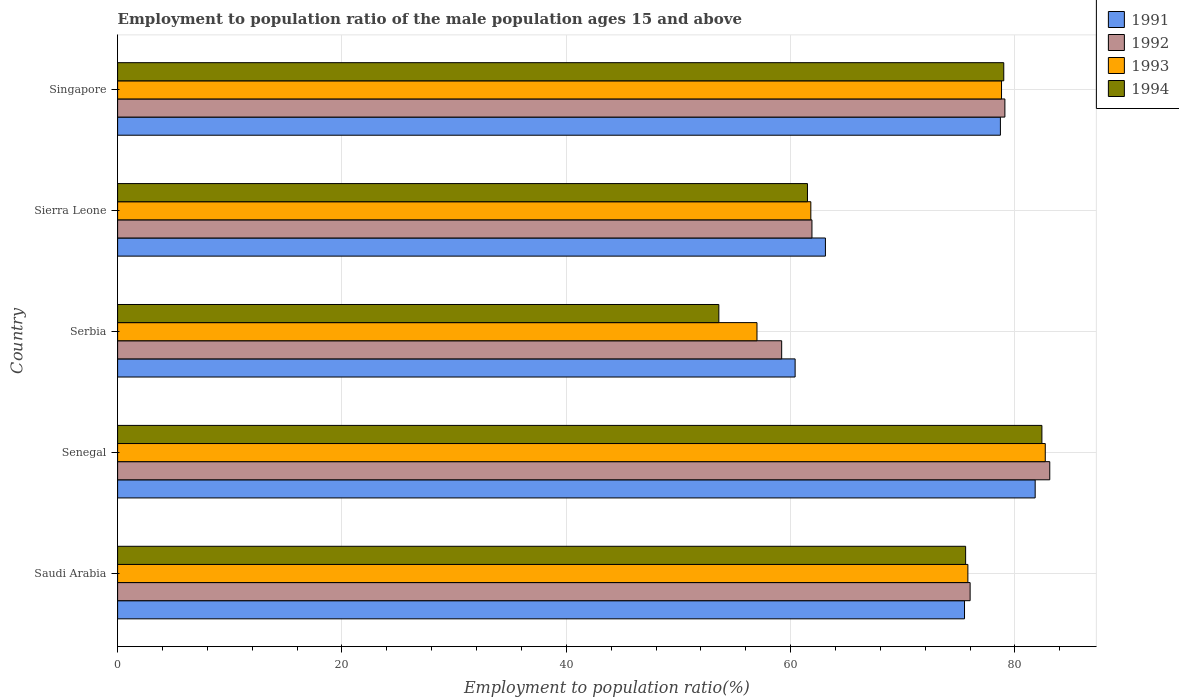How many groups of bars are there?
Your response must be concise. 5. Are the number of bars per tick equal to the number of legend labels?
Provide a succinct answer. Yes. How many bars are there on the 4th tick from the top?
Your answer should be very brief. 4. What is the label of the 5th group of bars from the top?
Provide a succinct answer. Saudi Arabia. In how many cases, is the number of bars for a given country not equal to the number of legend labels?
Your response must be concise. 0. Across all countries, what is the maximum employment to population ratio in 1993?
Offer a terse response. 82.7. Across all countries, what is the minimum employment to population ratio in 1993?
Make the answer very short. 57. In which country was the employment to population ratio in 1993 maximum?
Give a very brief answer. Senegal. In which country was the employment to population ratio in 1993 minimum?
Give a very brief answer. Serbia. What is the total employment to population ratio in 1991 in the graph?
Your answer should be compact. 359.5. What is the difference between the employment to population ratio in 1991 in Saudi Arabia and that in Singapore?
Offer a very short reply. -3.2. What is the difference between the employment to population ratio in 1994 in Singapore and the employment to population ratio in 1991 in Saudi Arabia?
Provide a succinct answer. 3.5. What is the average employment to population ratio in 1991 per country?
Your answer should be compact. 71.9. What is the difference between the employment to population ratio in 1991 and employment to population ratio in 1992 in Singapore?
Your answer should be compact. -0.4. What is the ratio of the employment to population ratio in 1992 in Saudi Arabia to that in Serbia?
Offer a very short reply. 1.28. Is the difference between the employment to population ratio in 1991 in Saudi Arabia and Senegal greater than the difference between the employment to population ratio in 1992 in Saudi Arabia and Senegal?
Offer a terse response. Yes. What is the difference between the highest and the second highest employment to population ratio in 1994?
Keep it short and to the point. 3.4. What is the difference between the highest and the lowest employment to population ratio in 1994?
Offer a terse response. 28.8. Is it the case that in every country, the sum of the employment to population ratio in 1991 and employment to population ratio in 1994 is greater than the employment to population ratio in 1993?
Ensure brevity in your answer.  Yes. How many countries are there in the graph?
Your answer should be very brief. 5. Does the graph contain any zero values?
Offer a terse response. No. What is the title of the graph?
Your answer should be compact. Employment to population ratio of the male population ages 15 and above. What is the Employment to population ratio(%) in 1991 in Saudi Arabia?
Provide a succinct answer. 75.5. What is the Employment to population ratio(%) in 1992 in Saudi Arabia?
Give a very brief answer. 76. What is the Employment to population ratio(%) in 1993 in Saudi Arabia?
Give a very brief answer. 75.8. What is the Employment to population ratio(%) in 1994 in Saudi Arabia?
Your answer should be compact. 75.6. What is the Employment to population ratio(%) in 1991 in Senegal?
Give a very brief answer. 81.8. What is the Employment to population ratio(%) in 1992 in Senegal?
Your response must be concise. 83.1. What is the Employment to population ratio(%) of 1993 in Senegal?
Give a very brief answer. 82.7. What is the Employment to population ratio(%) in 1994 in Senegal?
Ensure brevity in your answer.  82.4. What is the Employment to population ratio(%) in 1991 in Serbia?
Offer a terse response. 60.4. What is the Employment to population ratio(%) of 1992 in Serbia?
Provide a short and direct response. 59.2. What is the Employment to population ratio(%) in 1994 in Serbia?
Make the answer very short. 53.6. What is the Employment to population ratio(%) of 1991 in Sierra Leone?
Give a very brief answer. 63.1. What is the Employment to population ratio(%) in 1992 in Sierra Leone?
Keep it short and to the point. 61.9. What is the Employment to population ratio(%) in 1993 in Sierra Leone?
Give a very brief answer. 61.8. What is the Employment to population ratio(%) in 1994 in Sierra Leone?
Provide a succinct answer. 61.5. What is the Employment to population ratio(%) in 1991 in Singapore?
Your answer should be compact. 78.7. What is the Employment to population ratio(%) of 1992 in Singapore?
Give a very brief answer. 79.1. What is the Employment to population ratio(%) in 1993 in Singapore?
Provide a short and direct response. 78.8. What is the Employment to population ratio(%) in 1994 in Singapore?
Your answer should be compact. 79. Across all countries, what is the maximum Employment to population ratio(%) of 1991?
Your response must be concise. 81.8. Across all countries, what is the maximum Employment to population ratio(%) of 1992?
Offer a terse response. 83.1. Across all countries, what is the maximum Employment to population ratio(%) of 1993?
Provide a succinct answer. 82.7. Across all countries, what is the maximum Employment to population ratio(%) of 1994?
Your answer should be compact. 82.4. Across all countries, what is the minimum Employment to population ratio(%) of 1991?
Make the answer very short. 60.4. Across all countries, what is the minimum Employment to population ratio(%) of 1992?
Your answer should be compact. 59.2. Across all countries, what is the minimum Employment to population ratio(%) of 1994?
Offer a very short reply. 53.6. What is the total Employment to population ratio(%) in 1991 in the graph?
Keep it short and to the point. 359.5. What is the total Employment to population ratio(%) in 1992 in the graph?
Ensure brevity in your answer.  359.3. What is the total Employment to population ratio(%) of 1993 in the graph?
Provide a succinct answer. 356.1. What is the total Employment to population ratio(%) in 1994 in the graph?
Give a very brief answer. 352.1. What is the difference between the Employment to population ratio(%) of 1991 in Saudi Arabia and that in Senegal?
Provide a short and direct response. -6.3. What is the difference between the Employment to population ratio(%) in 1992 in Saudi Arabia and that in Senegal?
Offer a terse response. -7.1. What is the difference between the Employment to population ratio(%) in 1993 in Saudi Arabia and that in Serbia?
Your answer should be compact. 18.8. What is the difference between the Employment to population ratio(%) of 1994 in Saudi Arabia and that in Serbia?
Your answer should be very brief. 22. What is the difference between the Employment to population ratio(%) in 1991 in Saudi Arabia and that in Sierra Leone?
Provide a short and direct response. 12.4. What is the difference between the Employment to population ratio(%) in 1994 in Saudi Arabia and that in Sierra Leone?
Make the answer very short. 14.1. What is the difference between the Employment to population ratio(%) in 1991 in Saudi Arabia and that in Singapore?
Ensure brevity in your answer.  -3.2. What is the difference between the Employment to population ratio(%) of 1993 in Saudi Arabia and that in Singapore?
Ensure brevity in your answer.  -3. What is the difference between the Employment to population ratio(%) of 1994 in Saudi Arabia and that in Singapore?
Ensure brevity in your answer.  -3.4. What is the difference between the Employment to population ratio(%) in 1991 in Senegal and that in Serbia?
Provide a succinct answer. 21.4. What is the difference between the Employment to population ratio(%) of 1992 in Senegal and that in Serbia?
Keep it short and to the point. 23.9. What is the difference between the Employment to population ratio(%) in 1993 in Senegal and that in Serbia?
Make the answer very short. 25.7. What is the difference between the Employment to population ratio(%) of 1994 in Senegal and that in Serbia?
Provide a short and direct response. 28.8. What is the difference between the Employment to population ratio(%) in 1991 in Senegal and that in Sierra Leone?
Provide a succinct answer. 18.7. What is the difference between the Employment to population ratio(%) in 1992 in Senegal and that in Sierra Leone?
Your response must be concise. 21.2. What is the difference between the Employment to population ratio(%) in 1993 in Senegal and that in Sierra Leone?
Provide a succinct answer. 20.9. What is the difference between the Employment to population ratio(%) in 1994 in Senegal and that in Sierra Leone?
Provide a short and direct response. 20.9. What is the difference between the Employment to population ratio(%) in 1991 in Senegal and that in Singapore?
Your response must be concise. 3.1. What is the difference between the Employment to population ratio(%) in 1992 in Senegal and that in Singapore?
Your response must be concise. 4. What is the difference between the Employment to population ratio(%) of 1992 in Serbia and that in Sierra Leone?
Offer a terse response. -2.7. What is the difference between the Employment to population ratio(%) of 1994 in Serbia and that in Sierra Leone?
Provide a short and direct response. -7.9. What is the difference between the Employment to population ratio(%) in 1991 in Serbia and that in Singapore?
Provide a succinct answer. -18.3. What is the difference between the Employment to population ratio(%) of 1992 in Serbia and that in Singapore?
Your response must be concise. -19.9. What is the difference between the Employment to population ratio(%) of 1993 in Serbia and that in Singapore?
Your answer should be compact. -21.8. What is the difference between the Employment to population ratio(%) of 1994 in Serbia and that in Singapore?
Your answer should be compact. -25.4. What is the difference between the Employment to population ratio(%) of 1991 in Sierra Leone and that in Singapore?
Offer a terse response. -15.6. What is the difference between the Employment to population ratio(%) of 1992 in Sierra Leone and that in Singapore?
Give a very brief answer. -17.2. What is the difference between the Employment to population ratio(%) in 1993 in Sierra Leone and that in Singapore?
Your answer should be very brief. -17. What is the difference between the Employment to population ratio(%) of 1994 in Sierra Leone and that in Singapore?
Provide a succinct answer. -17.5. What is the difference between the Employment to population ratio(%) of 1991 in Saudi Arabia and the Employment to population ratio(%) of 1992 in Senegal?
Offer a very short reply. -7.6. What is the difference between the Employment to population ratio(%) of 1991 in Saudi Arabia and the Employment to population ratio(%) of 1994 in Senegal?
Your answer should be very brief. -6.9. What is the difference between the Employment to population ratio(%) in 1992 in Saudi Arabia and the Employment to population ratio(%) in 1993 in Senegal?
Provide a short and direct response. -6.7. What is the difference between the Employment to population ratio(%) in 1993 in Saudi Arabia and the Employment to population ratio(%) in 1994 in Senegal?
Make the answer very short. -6.6. What is the difference between the Employment to population ratio(%) in 1991 in Saudi Arabia and the Employment to population ratio(%) in 1992 in Serbia?
Offer a very short reply. 16.3. What is the difference between the Employment to population ratio(%) in 1991 in Saudi Arabia and the Employment to population ratio(%) in 1993 in Serbia?
Offer a terse response. 18.5. What is the difference between the Employment to population ratio(%) in 1991 in Saudi Arabia and the Employment to population ratio(%) in 1994 in Serbia?
Give a very brief answer. 21.9. What is the difference between the Employment to population ratio(%) of 1992 in Saudi Arabia and the Employment to population ratio(%) of 1994 in Serbia?
Your response must be concise. 22.4. What is the difference between the Employment to population ratio(%) in 1991 in Saudi Arabia and the Employment to population ratio(%) in 1992 in Sierra Leone?
Your answer should be compact. 13.6. What is the difference between the Employment to population ratio(%) in 1991 in Saudi Arabia and the Employment to population ratio(%) in 1994 in Singapore?
Your response must be concise. -3.5. What is the difference between the Employment to population ratio(%) of 1992 in Saudi Arabia and the Employment to population ratio(%) of 1994 in Singapore?
Provide a succinct answer. -3. What is the difference between the Employment to population ratio(%) of 1991 in Senegal and the Employment to population ratio(%) of 1992 in Serbia?
Offer a terse response. 22.6. What is the difference between the Employment to population ratio(%) in 1991 in Senegal and the Employment to population ratio(%) in 1993 in Serbia?
Keep it short and to the point. 24.8. What is the difference between the Employment to population ratio(%) of 1991 in Senegal and the Employment to population ratio(%) of 1994 in Serbia?
Your answer should be very brief. 28.2. What is the difference between the Employment to population ratio(%) of 1992 in Senegal and the Employment to population ratio(%) of 1993 in Serbia?
Provide a short and direct response. 26.1. What is the difference between the Employment to population ratio(%) in 1992 in Senegal and the Employment to population ratio(%) in 1994 in Serbia?
Offer a terse response. 29.5. What is the difference between the Employment to population ratio(%) of 1993 in Senegal and the Employment to population ratio(%) of 1994 in Serbia?
Keep it short and to the point. 29.1. What is the difference between the Employment to population ratio(%) of 1991 in Senegal and the Employment to population ratio(%) of 1992 in Sierra Leone?
Ensure brevity in your answer.  19.9. What is the difference between the Employment to population ratio(%) in 1991 in Senegal and the Employment to population ratio(%) in 1993 in Sierra Leone?
Provide a short and direct response. 20. What is the difference between the Employment to population ratio(%) in 1991 in Senegal and the Employment to population ratio(%) in 1994 in Sierra Leone?
Keep it short and to the point. 20.3. What is the difference between the Employment to population ratio(%) in 1992 in Senegal and the Employment to population ratio(%) in 1993 in Sierra Leone?
Your response must be concise. 21.3. What is the difference between the Employment to population ratio(%) of 1992 in Senegal and the Employment to population ratio(%) of 1994 in Sierra Leone?
Offer a very short reply. 21.6. What is the difference between the Employment to population ratio(%) in 1993 in Senegal and the Employment to population ratio(%) in 1994 in Sierra Leone?
Provide a short and direct response. 21.2. What is the difference between the Employment to population ratio(%) in 1991 in Senegal and the Employment to population ratio(%) in 1993 in Singapore?
Make the answer very short. 3. What is the difference between the Employment to population ratio(%) of 1991 in Serbia and the Employment to population ratio(%) of 1992 in Sierra Leone?
Provide a succinct answer. -1.5. What is the difference between the Employment to population ratio(%) of 1991 in Serbia and the Employment to population ratio(%) of 1994 in Sierra Leone?
Offer a very short reply. -1.1. What is the difference between the Employment to population ratio(%) in 1992 in Serbia and the Employment to population ratio(%) in 1994 in Sierra Leone?
Provide a succinct answer. -2.3. What is the difference between the Employment to population ratio(%) in 1993 in Serbia and the Employment to population ratio(%) in 1994 in Sierra Leone?
Provide a succinct answer. -4.5. What is the difference between the Employment to population ratio(%) in 1991 in Serbia and the Employment to population ratio(%) in 1992 in Singapore?
Keep it short and to the point. -18.7. What is the difference between the Employment to population ratio(%) of 1991 in Serbia and the Employment to population ratio(%) of 1993 in Singapore?
Your response must be concise. -18.4. What is the difference between the Employment to population ratio(%) of 1991 in Serbia and the Employment to population ratio(%) of 1994 in Singapore?
Your answer should be very brief. -18.6. What is the difference between the Employment to population ratio(%) in 1992 in Serbia and the Employment to population ratio(%) in 1993 in Singapore?
Ensure brevity in your answer.  -19.6. What is the difference between the Employment to population ratio(%) in 1992 in Serbia and the Employment to population ratio(%) in 1994 in Singapore?
Offer a very short reply. -19.8. What is the difference between the Employment to population ratio(%) in 1993 in Serbia and the Employment to population ratio(%) in 1994 in Singapore?
Your answer should be very brief. -22. What is the difference between the Employment to population ratio(%) in 1991 in Sierra Leone and the Employment to population ratio(%) in 1993 in Singapore?
Make the answer very short. -15.7. What is the difference between the Employment to population ratio(%) in 1991 in Sierra Leone and the Employment to population ratio(%) in 1994 in Singapore?
Provide a succinct answer. -15.9. What is the difference between the Employment to population ratio(%) of 1992 in Sierra Leone and the Employment to population ratio(%) of 1993 in Singapore?
Your answer should be compact. -16.9. What is the difference between the Employment to population ratio(%) in 1992 in Sierra Leone and the Employment to population ratio(%) in 1994 in Singapore?
Provide a succinct answer. -17.1. What is the difference between the Employment to population ratio(%) in 1993 in Sierra Leone and the Employment to population ratio(%) in 1994 in Singapore?
Provide a short and direct response. -17.2. What is the average Employment to population ratio(%) in 1991 per country?
Offer a terse response. 71.9. What is the average Employment to population ratio(%) of 1992 per country?
Keep it short and to the point. 71.86. What is the average Employment to population ratio(%) of 1993 per country?
Make the answer very short. 71.22. What is the average Employment to population ratio(%) of 1994 per country?
Ensure brevity in your answer.  70.42. What is the difference between the Employment to population ratio(%) in 1991 and Employment to population ratio(%) in 1994 in Saudi Arabia?
Offer a very short reply. -0.1. What is the difference between the Employment to population ratio(%) in 1992 and Employment to population ratio(%) in 1993 in Saudi Arabia?
Your answer should be compact. 0.2. What is the difference between the Employment to population ratio(%) of 1992 and Employment to population ratio(%) of 1994 in Saudi Arabia?
Provide a succinct answer. 0.4. What is the difference between the Employment to population ratio(%) in 1993 and Employment to population ratio(%) in 1994 in Saudi Arabia?
Your answer should be compact. 0.2. What is the difference between the Employment to population ratio(%) of 1991 and Employment to population ratio(%) of 1993 in Senegal?
Give a very brief answer. -0.9. What is the difference between the Employment to population ratio(%) in 1991 and Employment to population ratio(%) in 1994 in Senegal?
Make the answer very short. -0.6. What is the difference between the Employment to population ratio(%) in 1992 and Employment to population ratio(%) in 1993 in Senegal?
Provide a succinct answer. 0.4. What is the difference between the Employment to population ratio(%) in 1991 and Employment to population ratio(%) in 1992 in Serbia?
Your response must be concise. 1.2. What is the difference between the Employment to population ratio(%) of 1991 and Employment to population ratio(%) of 1993 in Serbia?
Provide a short and direct response. 3.4. What is the difference between the Employment to population ratio(%) in 1991 and Employment to population ratio(%) in 1992 in Sierra Leone?
Keep it short and to the point. 1.2. What is the difference between the Employment to population ratio(%) of 1992 and Employment to population ratio(%) of 1994 in Sierra Leone?
Provide a short and direct response. 0.4. What is the difference between the Employment to population ratio(%) in 1991 and Employment to population ratio(%) in 1992 in Singapore?
Keep it short and to the point. -0.4. What is the difference between the Employment to population ratio(%) in 1992 and Employment to population ratio(%) in 1993 in Singapore?
Your answer should be very brief. 0.3. What is the difference between the Employment to population ratio(%) of 1992 and Employment to population ratio(%) of 1994 in Singapore?
Provide a short and direct response. 0.1. What is the ratio of the Employment to population ratio(%) of 1991 in Saudi Arabia to that in Senegal?
Give a very brief answer. 0.92. What is the ratio of the Employment to population ratio(%) in 1992 in Saudi Arabia to that in Senegal?
Your response must be concise. 0.91. What is the ratio of the Employment to population ratio(%) in 1993 in Saudi Arabia to that in Senegal?
Your answer should be very brief. 0.92. What is the ratio of the Employment to population ratio(%) of 1994 in Saudi Arabia to that in Senegal?
Ensure brevity in your answer.  0.92. What is the ratio of the Employment to population ratio(%) in 1991 in Saudi Arabia to that in Serbia?
Provide a succinct answer. 1.25. What is the ratio of the Employment to population ratio(%) in 1992 in Saudi Arabia to that in Serbia?
Your response must be concise. 1.28. What is the ratio of the Employment to population ratio(%) of 1993 in Saudi Arabia to that in Serbia?
Ensure brevity in your answer.  1.33. What is the ratio of the Employment to population ratio(%) in 1994 in Saudi Arabia to that in Serbia?
Offer a very short reply. 1.41. What is the ratio of the Employment to population ratio(%) in 1991 in Saudi Arabia to that in Sierra Leone?
Provide a succinct answer. 1.2. What is the ratio of the Employment to population ratio(%) in 1992 in Saudi Arabia to that in Sierra Leone?
Keep it short and to the point. 1.23. What is the ratio of the Employment to population ratio(%) of 1993 in Saudi Arabia to that in Sierra Leone?
Make the answer very short. 1.23. What is the ratio of the Employment to population ratio(%) in 1994 in Saudi Arabia to that in Sierra Leone?
Provide a succinct answer. 1.23. What is the ratio of the Employment to population ratio(%) of 1991 in Saudi Arabia to that in Singapore?
Keep it short and to the point. 0.96. What is the ratio of the Employment to population ratio(%) in 1992 in Saudi Arabia to that in Singapore?
Your answer should be compact. 0.96. What is the ratio of the Employment to population ratio(%) in 1993 in Saudi Arabia to that in Singapore?
Provide a short and direct response. 0.96. What is the ratio of the Employment to population ratio(%) of 1991 in Senegal to that in Serbia?
Your response must be concise. 1.35. What is the ratio of the Employment to population ratio(%) in 1992 in Senegal to that in Serbia?
Give a very brief answer. 1.4. What is the ratio of the Employment to population ratio(%) of 1993 in Senegal to that in Serbia?
Your answer should be compact. 1.45. What is the ratio of the Employment to population ratio(%) in 1994 in Senegal to that in Serbia?
Offer a very short reply. 1.54. What is the ratio of the Employment to population ratio(%) in 1991 in Senegal to that in Sierra Leone?
Offer a very short reply. 1.3. What is the ratio of the Employment to population ratio(%) of 1992 in Senegal to that in Sierra Leone?
Provide a short and direct response. 1.34. What is the ratio of the Employment to population ratio(%) of 1993 in Senegal to that in Sierra Leone?
Give a very brief answer. 1.34. What is the ratio of the Employment to population ratio(%) of 1994 in Senegal to that in Sierra Leone?
Keep it short and to the point. 1.34. What is the ratio of the Employment to population ratio(%) in 1991 in Senegal to that in Singapore?
Offer a very short reply. 1.04. What is the ratio of the Employment to population ratio(%) of 1992 in Senegal to that in Singapore?
Offer a terse response. 1.05. What is the ratio of the Employment to population ratio(%) in 1993 in Senegal to that in Singapore?
Your answer should be very brief. 1.05. What is the ratio of the Employment to population ratio(%) in 1994 in Senegal to that in Singapore?
Your answer should be very brief. 1.04. What is the ratio of the Employment to population ratio(%) of 1991 in Serbia to that in Sierra Leone?
Your response must be concise. 0.96. What is the ratio of the Employment to population ratio(%) of 1992 in Serbia to that in Sierra Leone?
Provide a short and direct response. 0.96. What is the ratio of the Employment to population ratio(%) in 1993 in Serbia to that in Sierra Leone?
Give a very brief answer. 0.92. What is the ratio of the Employment to population ratio(%) of 1994 in Serbia to that in Sierra Leone?
Your response must be concise. 0.87. What is the ratio of the Employment to population ratio(%) of 1991 in Serbia to that in Singapore?
Give a very brief answer. 0.77. What is the ratio of the Employment to population ratio(%) in 1992 in Serbia to that in Singapore?
Provide a short and direct response. 0.75. What is the ratio of the Employment to population ratio(%) of 1993 in Serbia to that in Singapore?
Your answer should be very brief. 0.72. What is the ratio of the Employment to population ratio(%) of 1994 in Serbia to that in Singapore?
Keep it short and to the point. 0.68. What is the ratio of the Employment to population ratio(%) in 1991 in Sierra Leone to that in Singapore?
Keep it short and to the point. 0.8. What is the ratio of the Employment to population ratio(%) in 1992 in Sierra Leone to that in Singapore?
Provide a short and direct response. 0.78. What is the ratio of the Employment to population ratio(%) of 1993 in Sierra Leone to that in Singapore?
Offer a terse response. 0.78. What is the ratio of the Employment to population ratio(%) in 1994 in Sierra Leone to that in Singapore?
Make the answer very short. 0.78. What is the difference between the highest and the second highest Employment to population ratio(%) in 1993?
Make the answer very short. 3.9. What is the difference between the highest and the lowest Employment to population ratio(%) of 1991?
Keep it short and to the point. 21.4. What is the difference between the highest and the lowest Employment to population ratio(%) of 1992?
Provide a short and direct response. 23.9. What is the difference between the highest and the lowest Employment to population ratio(%) in 1993?
Your answer should be very brief. 25.7. What is the difference between the highest and the lowest Employment to population ratio(%) in 1994?
Give a very brief answer. 28.8. 